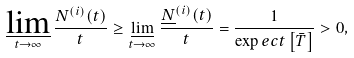Convert formula to latex. <formula><loc_0><loc_0><loc_500><loc_500>\varliminf _ { t \to \infty } \frac { N ^ { ( i ) } ( t ) } { t } & \geq \varliminf _ { t \to \infty } \frac { \underline { N } ^ { ( i ) } ( t ) } { t } = \frac { 1 } { \exp e c t \left [ \bar { T } \right ] } > 0 ,</formula> 